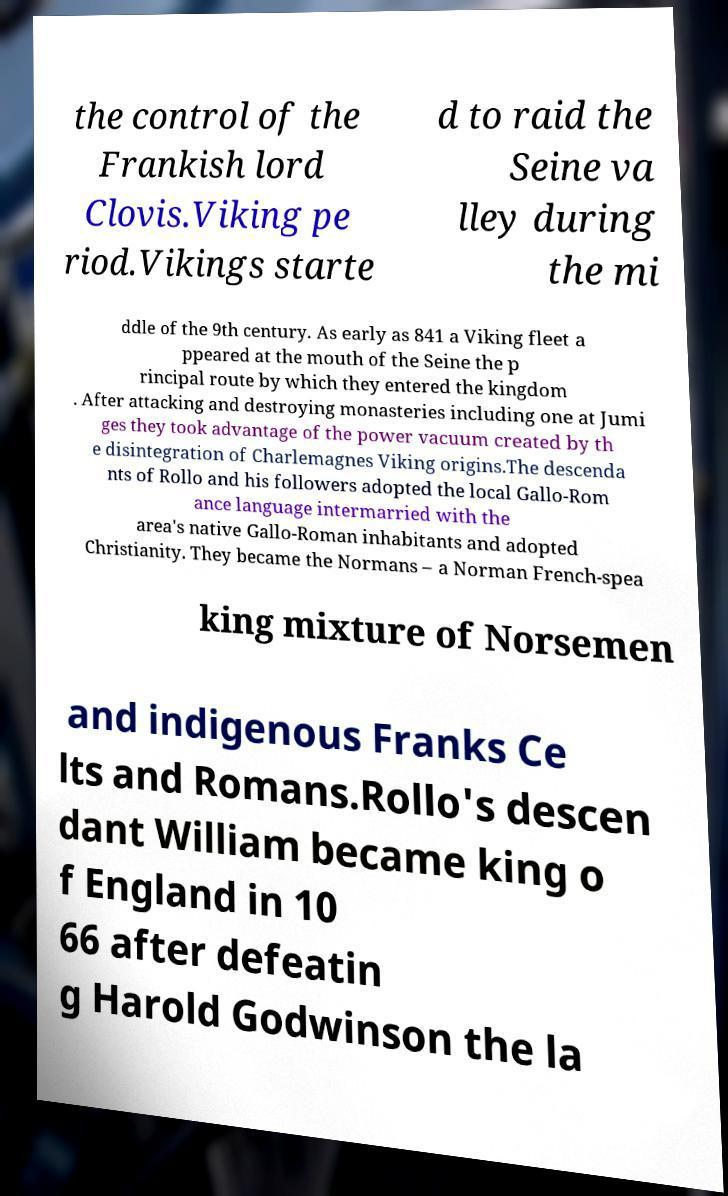Can you read and provide the text displayed in the image?This photo seems to have some interesting text. Can you extract and type it out for me? the control of the Frankish lord Clovis.Viking pe riod.Vikings starte d to raid the Seine va lley during the mi ddle of the 9th century. As early as 841 a Viking fleet a ppeared at the mouth of the Seine the p rincipal route by which they entered the kingdom . After attacking and destroying monasteries including one at Jumi ges they took advantage of the power vacuum created by th e disintegration of Charlemagnes Viking origins.The descenda nts of Rollo and his followers adopted the local Gallo-Rom ance language intermarried with the area's native Gallo-Roman inhabitants and adopted Christianity. They became the Normans – a Norman French-spea king mixture of Norsemen and indigenous Franks Ce lts and Romans.Rollo's descen dant William became king o f England in 10 66 after defeatin g Harold Godwinson the la 